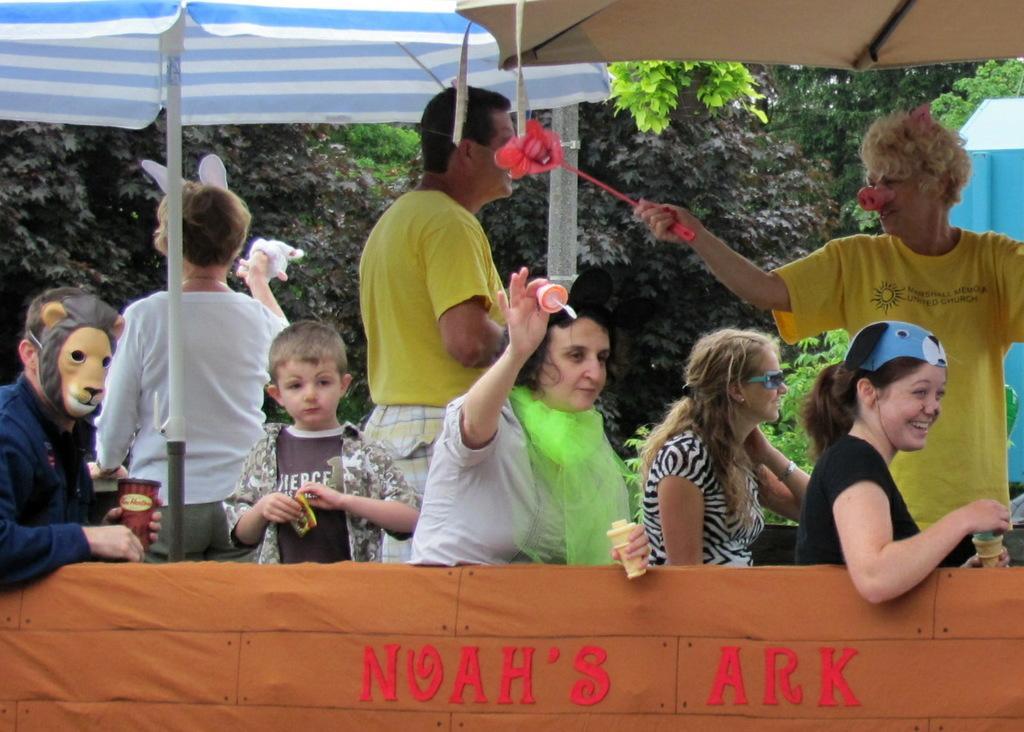In one or two sentences, can you explain what this image depicts? In this image I can see few people are holding something and wearing masks. Back I can see few umbrellas and trees. 